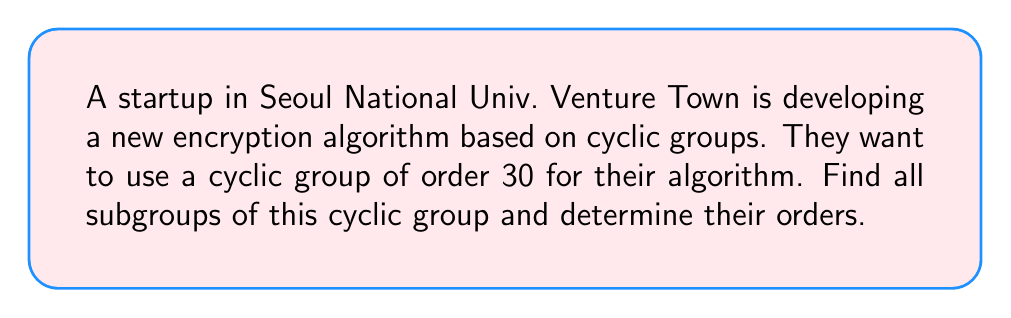Can you answer this question? Let's approach this step-by-step:

1) First, recall that for a cyclic group $G$ of order $n$, the subgroups of $G$ are in one-to-one correspondence with the divisors of $n$.

2) The divisors of 30 are: 1, 2, 3, 5, 6, 10, 15, and 30.

3) Let $a$ be a generator of the cyclic group of order 30. We can represent this group as:

   $G = \langle a \rangle = \{e, a, a^2, ..., a^{29}\}$

4) For each divisor $d$ of 30, there is a unique subgroup of order $d$. This subgroup is generated by $a^{30/d}$. Let's find each subgroup:

   - For $d = 1$: $\langle a^{30} \rangle = \{e\}$
   - For $d = 2$: $\langle a^{15} \rangle = \{e, a^{15}\}$
   - For $d = 3$: $\langle a^{10} \rangle = \{e, a^{10}, a^{20}\}$
   - For $d = 5$: $\langle a^6 \rangle = \{e, a^6, a^{12}, a^{18}, a^{24}\}$
   - For $d = 6$: $\langle a^5 \rangle = \{e, a^5, a^{10}, a^{15}, a^{20}, a^{25}\}$
   - For $d = 10$: $\langle a^3 \rangle = \{e, a^3, a^6, a^9, ..., a^{27}\}$
   - For $d = 15$: $\langle a^2 \rangle = \{e, a^2, a^4, a^6, ..., a^{28}\}$
   - For $d = 30$: $\langle a \rangle = G$ (the whole group)

5) Therefore, we have found all 8 subgroups of the cyclic group of order 30.
Answer: The cyclic group of order 30 has 8 subgroups:

1. $\{e\}$ (order 1)
2. $\langle a^{15} \rangle$ (order 2)
3. $\langle a^{10} \rangle$ (order 3)
4. $\langle a^6 \rangle$ (order 5)
5. $\langle a^5 \rangle$ (order 6)
6. $\langle a^3 \rangle$ (order 10)
7. $\langle a^2 \rangle$ (order 15)
8. $\langle a \rangle$ (order 30)

Where $a$ is a generator of the cyclic group. 